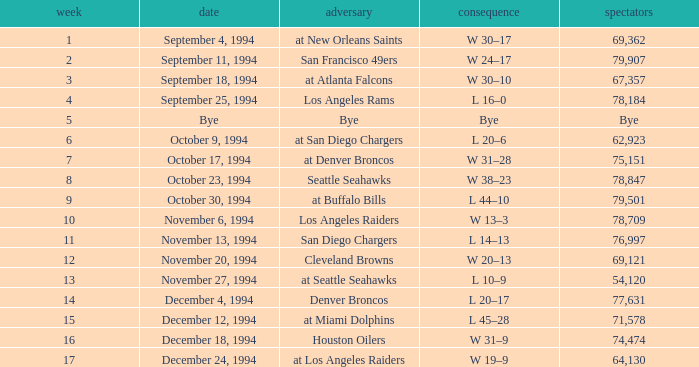What was the score of the Chiefs pre-Week 16 game that 69,362 people attended? W 30–17. 